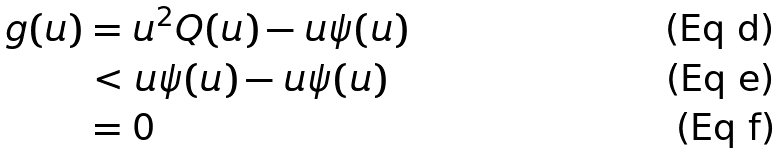Convert formula to latex. <formula><loc_0><loc_0><loc_500><loc_500>g ( u ) & = u ^ { 2 } Q ( u ) - u \psi ( u ) \\ & < u \psi ( u ) - u \psi ( u ) \\ & = 0</formula> 